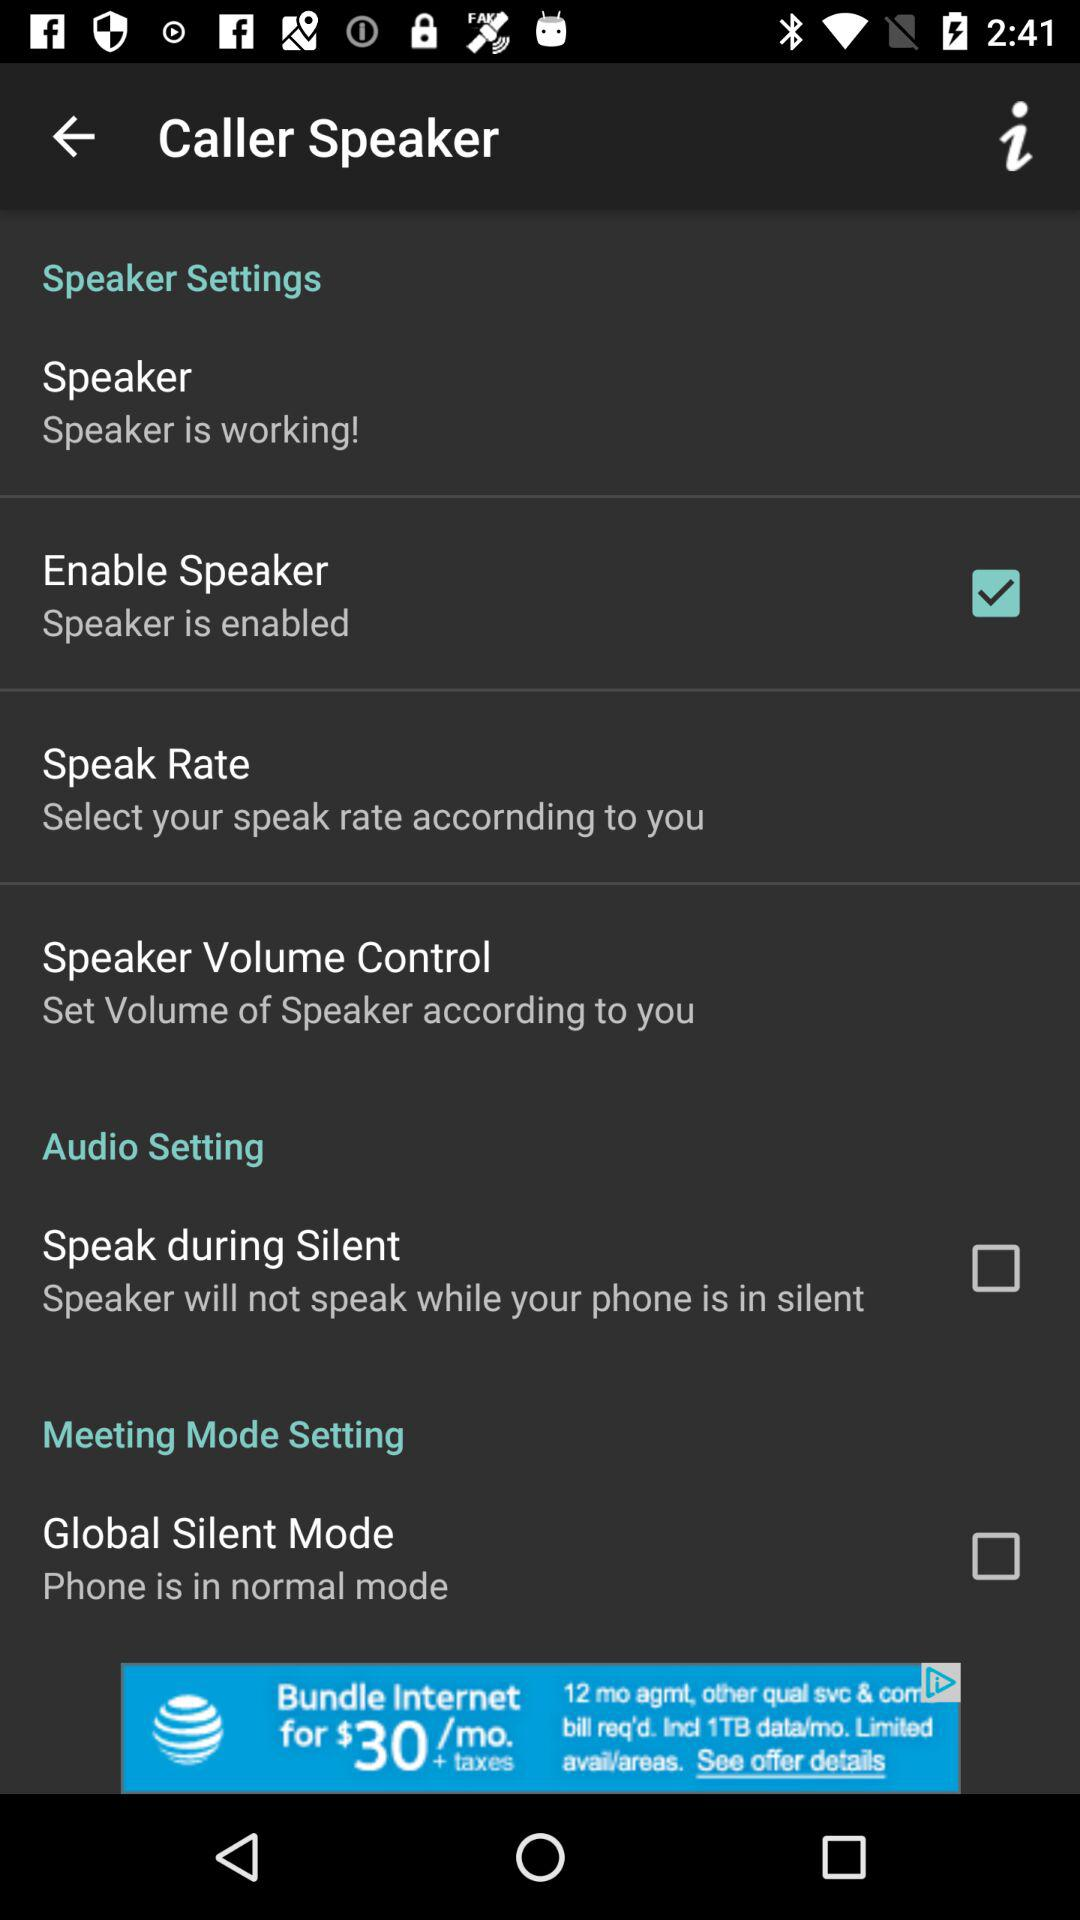Which option is selected? The selected option is "Enable Speaker". 